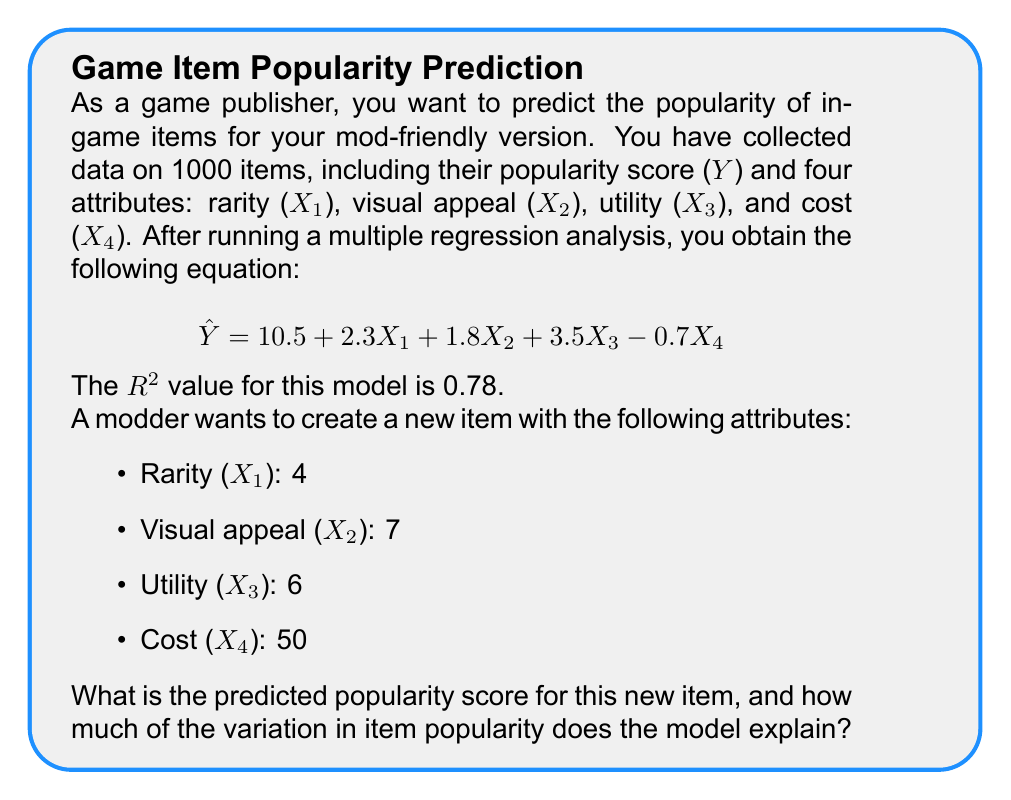Show me your answer to this math problem. To solve this problem, we'll follow these steps:

1. Calculate the predicted popularity score using the given regression equation.
2. Interpret the R² value.

Step 1: Calculating the predicted popularity score

We'll use the multiple regression equation:
$$ \hat{Y} = 10.5 + 2.3X_1 + 1.8X_2 + 3.5X_3 - 0.7X_4 $$

Substituting the values for the new item:
$$ \hat{Y} = 10.5 + 2.3(4) + 1.8(7) + 3.5(6) - 0.7(50) $$

$$ \hat{Y} = 10.5 + 9.2 + 12.6 + 21 - 35 $$

$$ \hat{Y} = 18.3 $$

Step 2: Interpreting the R² value

The R² value of 0.78 indicates that 78% of the variation in item popularity can be explained by the four attributes in the model (rarity, visual appeal, utility, and cost).

This means that the model accounts for a substantial portion of the factors influencing item popularity, but there may be other factors not included in the model that also affect popularity.
Answer: Predicted popularity score: 18.3; Model explains 78% of variation in item popularity. 